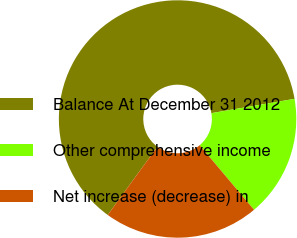<chart> <loc_0><loc_0><loc_500><loc_500><pie_chart><fcel>Balance At December 31 2012<fcel>Other comprehensive income<fcel>Net increase (decrease) in<nl><fcel>62.28%<fcel>16.58%<fcel>21.15%<nl></chart> 